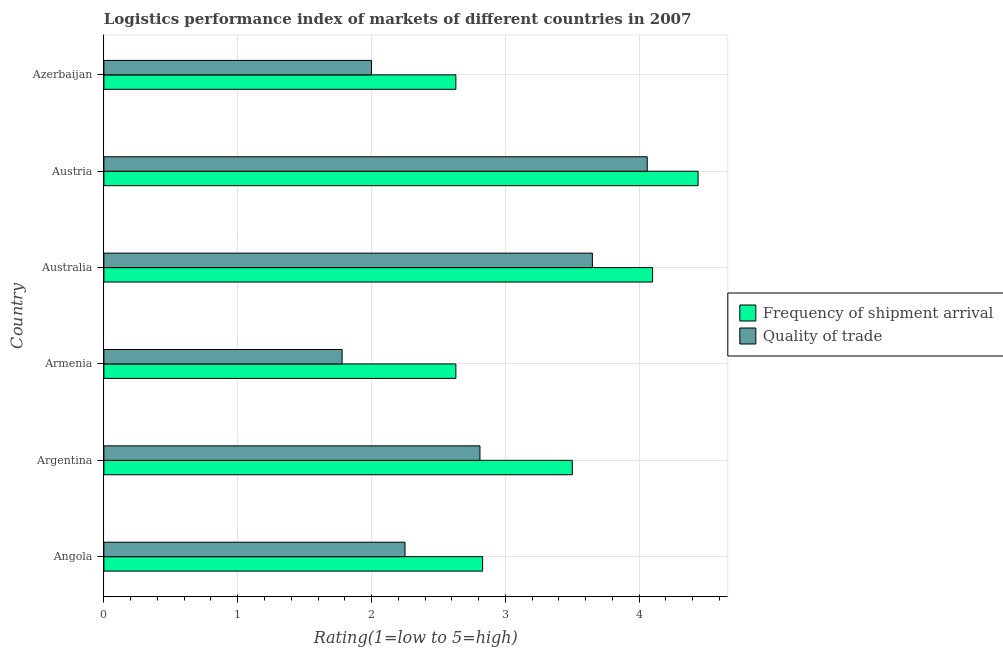How many different coloured bars are there?
Your answer should be very brief. 2. Are the number of bars on each tick of the Y-axis equal?
Keep it short and to the point. Yes. How many bars are there on the 6th tick from the top?
Provide a succinct answer. 2. How many bars are there on the 1st tick from the bottom?
Your answer should be very brief. 2. In how many cases, is the number of bars for a given country not equal to the number of legend labels?
Make the answer very short. 0. What is the lpi of frequency of shipment arrival in Angola?
Give a very brief answer. 2.83. Across all countries, what is the maximum lpi quality of trade?
Ensure brevity in your answer.  4.06. Across all countries, what is the minimum lpi of frequency of shipment arrival?
Offer a terse response. 2.63. In which country was the lpi quality of trade minimum?
Give a very brief answer. Armenia. What is the total lpi of frequency of shipment arrival in the graph?
Keep it short and to the point. 20.13. What is the difference between the lpi of frequency of shipment arrival in Angola and that in Austria?
Offer a very short reply. -1.61. What is the average lpi quality of trade per country?
Your answer should be compact. 2.76. What is the difference between the lpi of frequency of shipment arrival and lpi quality of trade in Azerbaijan?
Give a very brief answer. 0.63. In how many countries, is the lpi of frequency of shipment arrival greater than 4.2 ?
Offer a terse response. 1. What is the ratio of the lpi of frequency of shipment arrival in Armenia to that in Austria?
Your answer should be very brief. 0.59. Is the difference between the lpi of frequency of shipment arrival in Argentina and Azerbaijan greater than the difference between the lpi quality of trade in Argentina and Azerbaijan?
Your response must be concise. Yes. What is the difference between the highest and the second highest lpi of frequency of shipment arrival?
Your answer should be compact. 0.34. What is the difference between the highest and the lowest lpi quality of trade?
Make the answer very short. 2.28. Is the sum of the lpi of frequency of shipment arrival in Argentina and Austria greater than the maximum lpi quality of trade across all countries?
Keep it short and to the point. Yes. What does the 2nd bar from the top in Angola represents?
Your answer should be compact. Frequency of shipment arrival. What does the 1st bar from the bottom in Angola represents?
Offer a very short reply. Frequency of shipment arrival. How many bars are there?
Offer a terse response. 12. How many countries are there in the graph?
Offer a very short reply. 6. What is the difference between two consecutive major ticks on the X-axis?
Provide a short and direct response. 1. Are the values on the major ticks of X-axis written in scientific E-notation?
Provide a short and direct response. No. Does the graph contain any zero values?
Your answer should be compact. No. Does the graph contain grids?
Make the answer very short. Yes. How are the legend labels stacked?
Make the answer very short. Vertical. What is the title of the graph?
Give a very brief answer. Logistics performance index of markets of different countries in 2007. What is the label or title of the X-axis?
Make the answer very short. Rating(1=low to 5=high). What is the label or title of the Y-axis?
Give a very brief answer. Country. What is the Rating(1=low to 5=high) of Frequency of shipment arrival in Angola?
Your answer should be very brief. 2.83. What is the Rating(1=low to 5=high) of Quality of trade in Angola?
Ensure brevity in your answer.  2.25. What is the Rating(1=low to 5=high) of Frequency of shipment arrival in Argentina?
Keep it short and to the point. 3.5. What is the Rating(1=low to 5=high) in Quality of trade in Argentina?
Your answer should be very brief. 2.81. What is the Rating(1=low to 5=high) in Frequency of shipment arrival in Armenia?
Your answer should be compact. 2.63. What is the Rating(1=low to 5=high) in Quality of trade in Armenia?
Ensure brevity in your answer.  1.78. What is the Rating(1=low to 5=high) of Quality of trade in Australia?
Give a very brief answer. 3.65. What is the Rating(1=low to 5=high) in Frequency of shipment arrival in Austria?
Offer a terse response. 4.44. What is the Rating(1=low to 5=high) in Quality of trade in Austria?
Keep it short and to the point. 4.06. What is the Rating(1=low to 5=high) of Frequency of shipment arrival in Azerbaijan?
Provide a succinct answer. 2.63. What is the Rating(1=low to 5=high) of Quality of trade in Azerbaijan?
Provide a short and direct response. 2. Across all countries, what is the maximum Rating(1=low to 5=high) in Frequency of shipment arrival?
Your response must be concise. 4.44. Across all countries, what is the maximum Rating(1=low to 5=high) in Quality of trade?
Give a very brief answer. 4.06. Across all countries, what is the minimum Rating(1=low to 5=high) in Frequency of shipment arrival?
Provide a short and direct response. 2.63. Across all countries, what is the minimum Rating(1=low to 5=high) of Quality of trade?
Ensure brevity in your answer.  1.78. What is the total Rating(1=low to 5=high) in Frequency of shipment arrival in the graph?
Ensure brevity in your answer.  20.13. What is the total Rating(1=low to 5=high) in Quality of trade in the graph?
Keep it short and to the point. 16.55. What is the difference between the Rating(1=low to 5=high) of Frequency of shipment arrival in Angola and that in Argentina?
Your response must be concise. -0.67. What is the difference between the Rating(1=low to 5=high) of Quality of trade in Angola and that in Argentina?
Make the answer very short. -0.56. What is the difference between the Rating(1=low to 5=high) in Quality of trade in Angola and that in Armenia?
Your answer should be compact. 0.47. What is the difference between the Rating(1=low to 5=high) of Frequency of shipment arrival in Angola and that in Australia?
Provide a short and direct response. -1.27. What is the difference between the Rating(1=low to 5=high) of Frequency of shipment arrival in Angola and that in Austria?
Your answer should be compact. -1.61. What is the difference between the Rating(1=low to 5=high) of Quality of trade in Angola and that in Austria?
Ensure brevity in your answer.  -1.81. What is the difference between the Rating(1=low to 5=high) of Frequency of shipment arrival in Angola and that in Azerbaijan?
Your response must be concise. 0.2. What is the difference between the Rating(1=low to 5=high) of Quality of trade in Angola and that in Azerbaijan?
Make the answer very short. 0.25. What is the difference between the Rating(1=low to 5=high) of Frequency of shipment arrival in Argentina and that in Armenia?
Make the answer very short. 0.87. What is the difference between the Rating(1=low to 5=high) of Quality of trade in Argentina and that in Armenia?
Your answer should be compact. 1.03. What is the difference between the Rating(1=low to 5=high) in Frequency of shipment arrival in Argentina and that in Australia?
Keep it short and to the point. -0.6. What is the difference between the Rating(1=low to 5=high) of Quality of trade in Argentina and that in Australia?
Give a very brief answer. -0.84. What is the difference between the Rating(1=low to 5=high) of Frequency of shipment arrival in Argentina and that in Austria?
Make the answer very short. -0.94. What is the difference between the Rating(1=low to 5=high) of Quality of trade in Argentina and that in Austria?
Make the answer very short. -1.25. What is the difference between the Rating(1=low to 5=high) in Frequency of shipment arrival in Argentina and that in Azerbaijan?
Offer a very short reply. 0.87. What is the difference between the Rating(1=low to 5=high) of Quality of trade in Argentina and that in Azerbaijan?
Your answer should be very brief. 0.81. What is the difference between the Rating(1=low to 5=high) of Frequency of shipment arrival in Armenia and that in Australia?
Offer a terse response. -1.47. What is the difference between the Rating(1=low to 5=high) of Quality of trade in Armenia and that in Australia?
Your response must be concise. -1.87. What is the difference between the Rating(1=low to 5=high) of Frequency of shipment arrival in Armenia and that in Austria?
Ensure brevity in your answer.  -1.81. What is the difference between the Rating(1=low to 5=high) in Quality of trade in Armenia and that in Austria?
Your response must be concise. -2.28. What is the difference between the Rating(1=low to 5=high) of Frequency of shipment arrival in Armenia and that in Azerbaijan?
Offer a very short reply. 0. What is the difference between the Rating(1=low to 5=high) of Quality of trade in Armenia and that in Azerbaijan?
Make the answer very short. -0.22. What is the difference between the Rating(1=low to 5=high) in Frequency of shipment arrival in Australia and that in Austria?
Keep it short and to the point. -0.34. What is the difference between the Rating(1=low to 5=high) in Quality of trade in Australia and that in Austria?
Keep it short and to the point. -0.41. What is the difference between the Rating(1=low to 5=high) of Frequency of shipment arrival in Australia and that in Azerbaijan?
Your answer should be compact. 1.47. What is the difference between the Rating(1=low to 5=high) in Quality of trade in Australia and that in Azerbaijan?
Your response must be concise. 1.65. What is the difference between the Rating(1=low to 5=high) of Frequency of shipment arrival in Austria and that in Azerbaijan?
Make the answer very short. 1.81. What is the difference between the Rating(1=low to 5=high) in Quality of trade in Austria and that in Azerbaijan?
Keep it short and to the point. 2.06. What is the difference between the Rating(1=low to 5=high) in Frequency of shipment arrival in Angola and the Rating(1=low to 5=high) in Quality of trade in Armenia?
Offer a very short reply. 1.05. What is the difference between the Rating(1=low to 5=high) in Frequency of shipment arrival in Angola and the Rating(1=low to 5=high) in Quality of trade in Australia?
Ensure brevity in your answer.  -0.82. What is the difference between the Rating(1=low to 5=high) of Frequency of shipment arrival in Angola and the Rating(1=low to 5=high) of Quality of trade in Austria?
Offer a very short reply. -1.23. What is the difference between the Rating(1=low to 5=high) of Frequency of shipment arrival in Angola and the Rating(1=low to 5=high) of Quality of trade in Azerbaijan?
Your answer should be compact. 0.83. What is the difference between the Rating(1=low to 5=high) of Frequency of shipment arrival in Argentina and the Rating(1=low to 5=high) of Quality of trade in Armenia?
Make the answer very short. 1.72. What is the difference between the Rating(1=low to 5=high) in Frequency of shipment arrival in Argentina and the Rating(1=low to 5=high) in Quality of trade in Austria?
Your answer should be very brief. -0.56. What is the difference between the Rating(1=low to 5=high) in Frequency of shipment arrival in Argentina and the Rating(1=low to 5=high) in Quality of trade in Azerbaijan?
Give a very brief answer. 1.5. What is the difference between the Rating(1=low to 5=high) of Frequency of shipment arrival in Armenia and the Rating(1=low to 5=high) of Quality of trade in Australia?
Offer a very short reply. -1.02. What is the difference between the Rating(1=low to 5=high) of Frequency of shipment arrival in Armenia and the Rating(1=low to 5=high) of Quality of trade in Austria?
Your answer should be compact. -1.43. What is the difference between the Rating(1=low to 5=high) in Frequency of shipment arrival in Armenia and the Rating(1=low to 5=high) in Quality of trade in Azerbaijan?
Provide a succinct answer. 0.63. What is the difference between the Rating(1=low to 5=high) in Frequency of shipment arrival in Australia and the Rating(1=low to 5=high) in Quality of trade in Austria?
Your answer should be compact. 0.04. What is the difference between the Rating(1=low to 5=high) in Frequency of shipment arrival in Australia and the Rating(1=low to 5=high) in Quality of trade in Azerbaijan?
Give a very brief answer. 2.1. What is the difference between the Rating(1=low to 5=high) of Frequency of shipment arrival in Austria and the Rating(1=low to 5=high) of Quality of trade in Azerbaijan?
Ensure brevity in your answer.  2.44. What is the average Rating(1=low to 5=high) of Frequency of shipment arrival per country?
Provide a short and direct response. 3.35. What is the average Rating(1=low to 5=high) of Quality of trade per country?
Your answer should be very brief. 2.76. What is the difference between the Rating(1=low to 5=high) of Frequency of shipment arrival and Rating(1=low to 5=high) of Quality of trade in Angola?
Keep it short and to the point. 0.58. What is the difference between the Rating(1=low to 5=high) of Frequency of shipment arrival and Rating(1=low to 5=high) of Quality of trade in Argentina?
Your answer should be very brief. 0.69. What is the difference between the Rating(1=low to 5=high) in Frequency of shipment arrival and Rating(1=low to 5=high) in Quality of trade in Australia?
Make the answer very short. 0.45. What is the difference between the Rating(1=low to 5=high) in Frequency of shipment arrival and Rating(1=low to 5=high) in Quality of trade in Austria?
Your response must be concise. 0.38. What is the difference between the Rating(1=low to 5=high) in Frequency of shipment arrival and Rating(1=low to 5=high) in Quality of trade in Azerbaijan?
Your response must be concise. 0.63. What is the ratio of the Rating(1=low to 5=high) in Frequency of shipment arrival in Angola to that in Argentina?
Offer a terse response. 0.81. What is the ratio of the Rating(1=low to 5=high) in Quality of trade in Angola to that in Argentina?
Your answer should be very brief. 0.8. What is the ratio of the Rating(1=low to 5=high) in Frequency of shipment arrival in Angola to that in Armenia?
Give a very brief answer. 1.08. What is the ratio of the Rating(1=low to 5=high) of Quality of trade in Angola to that in Armenia?
Your answer should be very brief. 1.26. What is the ratio of the Rating(1=low to 5=high) of Frequency of shipment arrival in Angola to that in Australia?
Your response must be concise. 0.69. What is the ratio of the Rating(1=low to 5=high) in Quality of trade in Angola to that in Australia?
Give a very brief answer. 0.62. What is the ratio of the Rating(1=low to 5=high) of Frequency of shipment arrival in Angola to that in Austria?
Give a very brief answer. 0.64. What is the ratio of the Rating(1=low to 5=high) in Quality of trade in Angola to that in Austria?
Your answer should be very brief. 0.55. What is the ratio of the Rating(1=low to 5=high) in Frequency of shipment arrival in Angola to that in Azerbaijan?
Your answer should be compact. 1.08. What is the ratio of the Rating(1=low to 5=high) of Quality of trade in Angola to that in Azerbaijan?
Give a very brief answer. 1.12. What is the ratio of the Rating(1=low to 5=high) in Frequency of shipment arrival in Argentina to that in Armenia?
Your response must be concise. 1.33. What is the ratio of the Rating(1=low to 5=high) in Quality of trade in Argentina to that in Armenia?
Offer a terse response. 1.58. What is the ratio of the Rating(1=low to 5=high) of Frequency of shipment arrival in Argentina to that in Australia?
Give a very brief answer. 0.85. What is the ratio of the Rating(1=low to 5=high) in Quality of trade in Argentina to that in Australia?
Offer a very short reply. 0.77. What is the ratio of the Rating(1=low to 5=high) of Frequency of shipment arrival in Argentina to that in Austria?
Keep it short and to the point. 0.79. What is the ratio of the Rating(1=low to 5=high) of Quality of trade in Argentina to that in Austria?
Keep it short and to the point. 0.69. What is the ratio of the Rating(1=low to 5=high) in Frequency of shipment arrival in Argentina to that in Azerbaijan?
Provide a short and direct response. 1.33. What is the ratio of the Rating(1=low to 5=high) of Quality of trade in Argentina to that in Azerbaijan?
Your response must be concise. 1.41. What is the ratio of the Rating(1=low to 5=high) of Frequency of shipment arrival in Armenia to that in Australia?
Offer a very short reply. 0.64. What is the ratio of the Rating(1=low to 5=high) of Quality of trade in Armenia to that in Australia?
Provide a short and direct response. 0.49. What is the ratio of the Rating(1=low to 5=high) in Frequency of shipment arrival in Armenia to that in Austria?
Provide a succinct answer. 0.59. What is the ratio of the Rating(1=low to 5=high) in Quality of trade in Armenia to that in Austria?
Offer a very short reply. 0.44. What is the ratio of the Rating(1=low to 5=high) of Quality of trade in Armenia to that in Azerbaijan?
Provide a succinct answer. 0.89. What is the ratio of the Rating(1=low to 5=high) of Frequency of shipment arrival in Australia to that in Austria?
Provide a short and direct response. 0.92. What is the ratio of the Rating(1=low to 5=high) in Quality of trade in Australia to that in Austria?
Make the answer very short. 0.9. What is the ratio of the Rating(1=low to 5=high) in Frequency of shipment arrival in Australia to that in Azerbaijan?
Your answer should be compact. 1.56. What is the ratio of the Rating(1=low to 5=high) of Quality of trade in Australia to that in Azerbaijan?
Offer a terse response. 1.82. What is the ratio of the Rating(1=low to 5=high) in Frequency of shipment arrival in Austria to that in Azerbaijan?
Give a very brief answer. 1.69. What is the ratio of the Rating(1=low to 5=high) of Quality of trade in Austria to that in Azerbaijan?
Offer a very short reply. 2.03. What is the difference between the highest and the second highest Rating(1=low to 5=high) in Frequency of shipment arrival?
Offer a very short reply. 0.34. What is the difference between the highest and the second highest Rating(1=low to 5=high) in Quality of trade?
Your answer should be compact. 0.41. What is the difference between the highest and the lowest Rating(1=low to 5=high) in Frequency of shipment arrival?
Offer a terse response. 1.81. What is the difference between the highest and the lowest Rating(1=low to 5=high) in Quality of trade?
Make the answer very short. 2.28. 